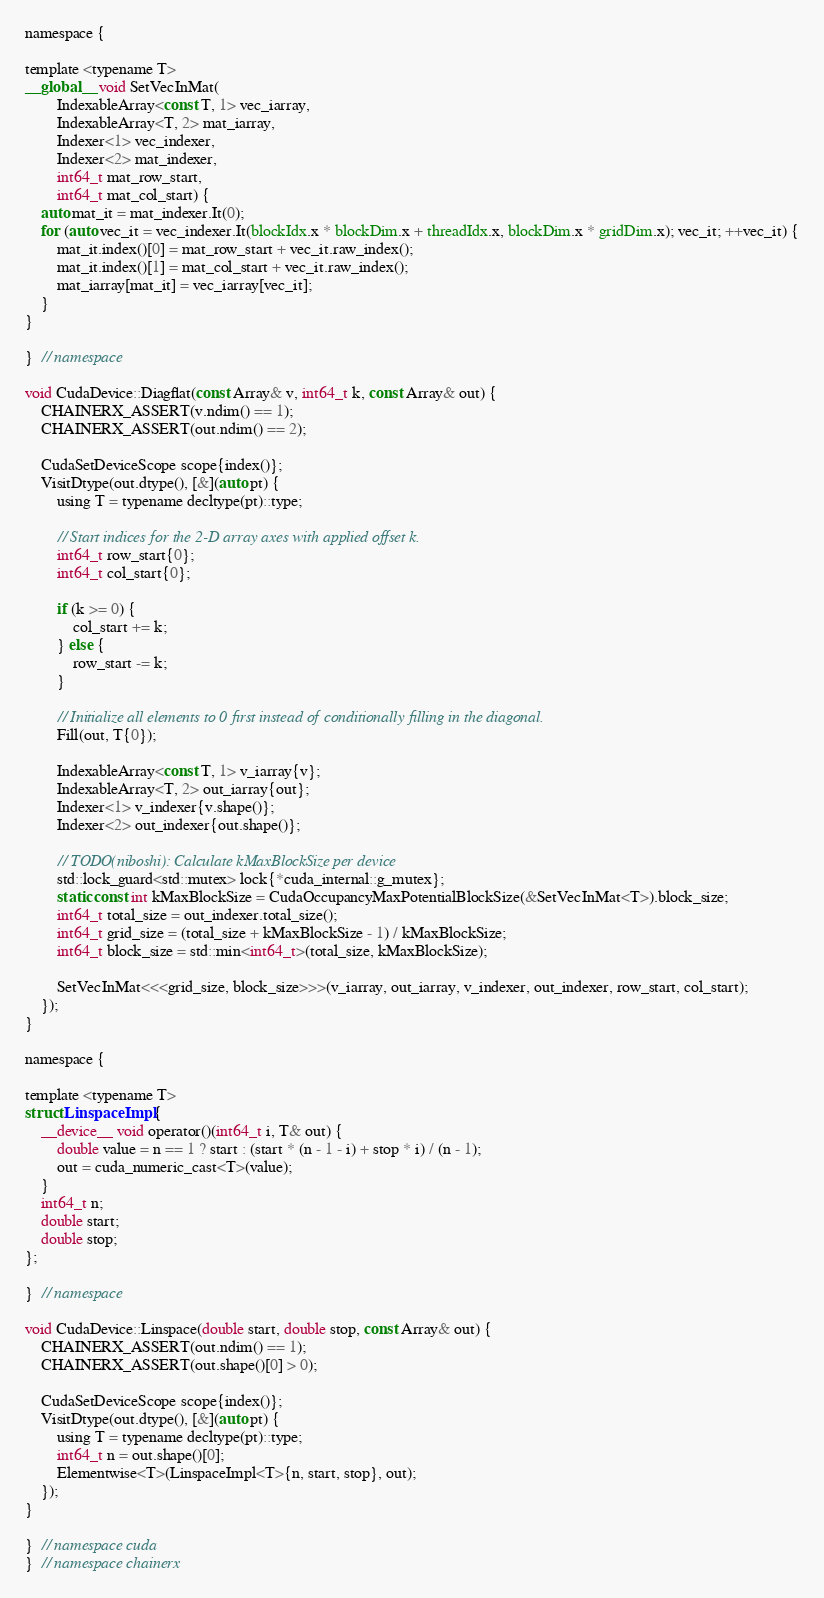<code> <loc_0><loc_0><loc_500><loc_500><_Cuda_>
namespace {

template <typename T>
__global__ void SetVecInMat(
        IndexableArray<const T, 1> vec_iarray,
        IndexableArray<T, 2> mat_iarray,
        Indexer<1> vec_indexer,
        Indexer<2> mat_indexer,
        int64_t mat_row_start,
        int64_t mat_col_start) {
    auto mat_it = mat_indexer.It(0);
    for (auto vec_it = vec_indexer.It(blockIdx.x * blockDim.x + threadIdx.x, blockDim.x * gridDim.x); vec_it; ++vec_it) {
        mat_it.index()[0] = mat_row_start + vec_it.raw_index();
        mat_it.index()[1] = mat_col_start + vec_it.raw_index();
        mat_iarray[mat_it] = vec_iarray[vec_it];
    }
}

}  // namespace

void CudaDevice::Diagflat(const Array& v, int64_t k, const Array& out) {
    CHAINERX_ASSERT(v.ndim() == 1);
    CHAINERX_ASSERT(out.ndim() == 2);

    CudaSetDeviceScope scope{index()};
    VisitDtype(out.dtype(), [&](auto pt) {
        using T = typename decltype(pt)::type;

        // Start indices for the 2-D array axes with applied offset k.
        int64_t row_start{0};
        int64_t col_start{0};

        if (k >= 0) {
            col_start += k;
        } else {
            row_start -= k;
        }

        // Initialize all elements to 0 first instead of conditionally filling in the diagonal.
        Fill(out, T{0});

        IndexableArray<const T, 1> v_iarray{v};
        IndexableArray<T, 2> out_iarray{out};
        Indexer<1> v_indexer{v.shape()};
        Indexer<2> out_indexer{out.shape()};

        // TODO(niboshi): Calculate kMaxBlockSize per device
        std::lock_guard<std::mutex> lock{*cuda_internal::g_mutex};
        static const int kMaxBlockSize = CudaOccupancyMaxPotentialBlockSize(&SetVecInMat<T>).block_size;
        int64_t total_size = out_indexer.total_size();
        int64_t grid_size = (total_size + kMaxBlockSize - 1) / kMaxBlockSize;
        int64_t block_size = std::min<int64_t>(total_size, kMaxBlockSize);

        SetVecInMat<<<grid_size, block_size>>>(v_iarray, out_iarray, v_indexer, out_indexer, row_start, col_start);
    });
}

namespace {

template <typename T>
struct LinspaceImpl {
    __device__ void operator()(int64_t i, T& out) {
        double value = n == 1 ? start : (start * (n - 1 - i) + stop * i) / (n - 1);
        out = cuda_numeric_cast<T>(value);
    }
    int64_t n;
    double start;
    double stop;
};

}  // namespace

void CudaDevice::Linspace(double start, double stop, const Array& out) {
    CHAINERX_ASSERT(out.ndim() == 1);
    CHAINERX_ASSERT(out.shape()[0] > 0);

    CudaSetDeviceScope scope{index()};
    VisitDtype(out.dtype(), [&](auto pt) {
        using T = typename decltype(pt)::type;
        int64_t n = out.shape()[0];
        Elementwise<T>(LinspaceImpl<T>{n, start, stop}, out);
    });
}

}  // namespace cuda
}  // namespace chainerx
</code> 